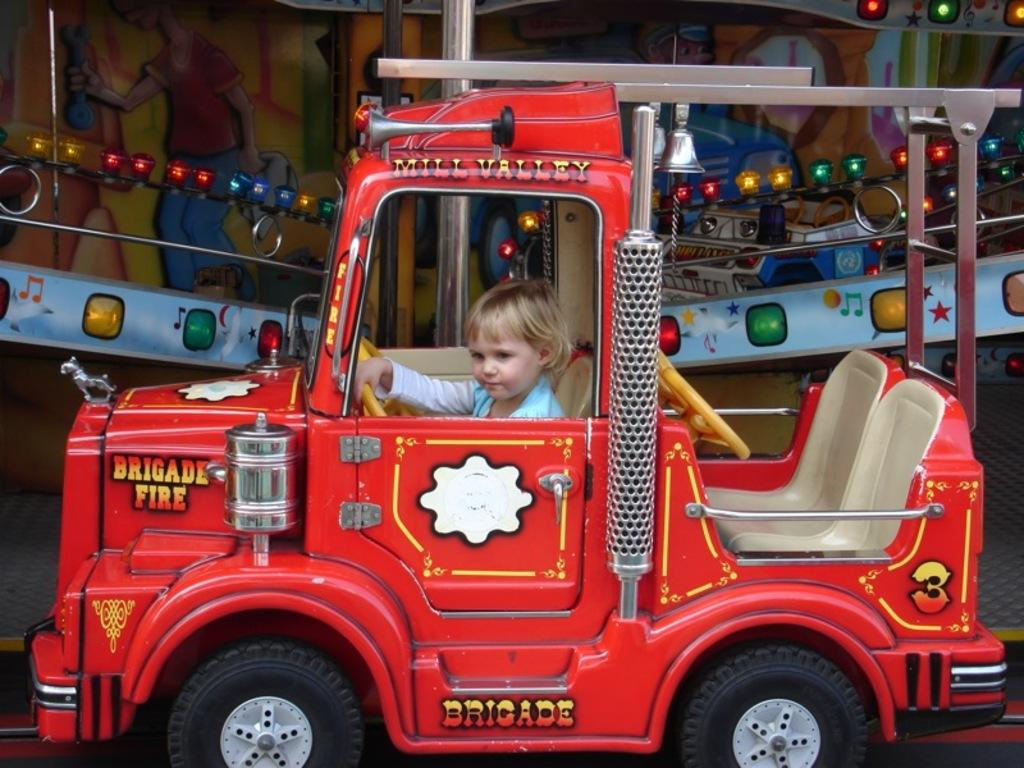What type of toy is in the image? There is a red toy car in the image. Who is inside the toy car? A baby is sitting inside the toy car. What is the baby doing with the toy car? The baby is holding the steering wheel. What can be seen in the background of the image? There are lights visible in the background of the image. What feeling does the baby have while sitting in the toy car? There is no indication of the baby's feelings in the image, so it cannot be determined. 